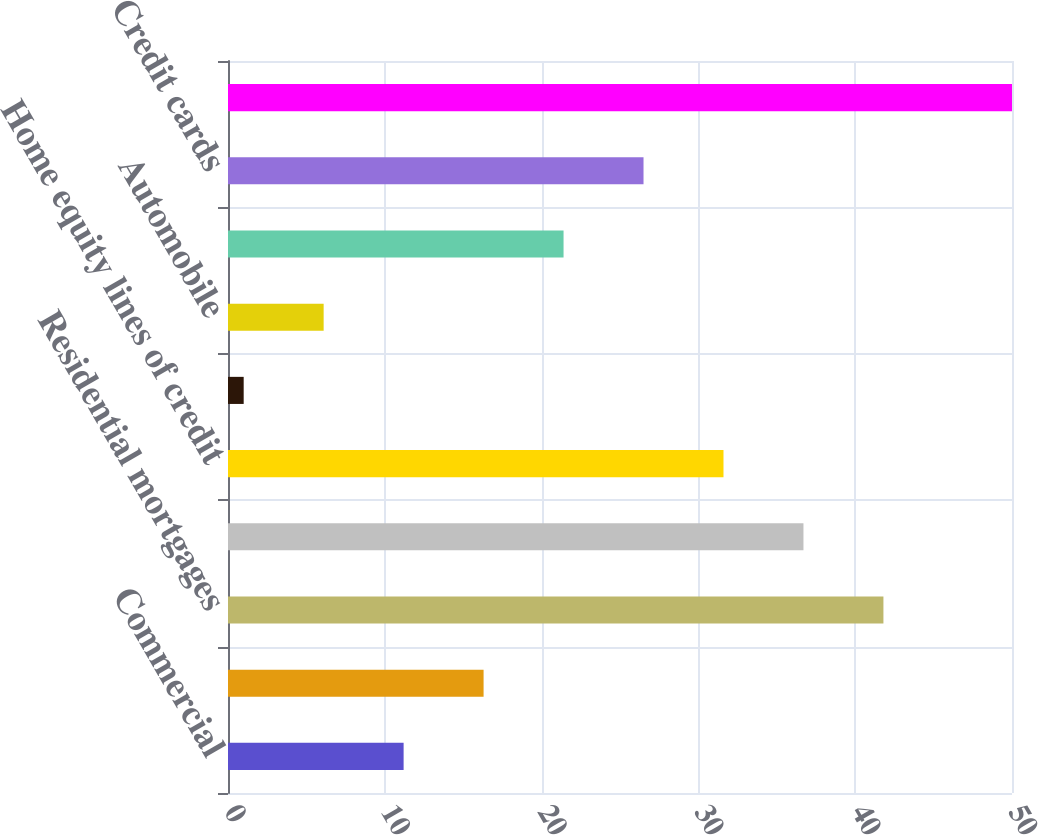<chart> <loc_0><loc_0><loc_500><loc_500><bar_chart><fcel>Commercial<fcel>Total commercial<fcel>Residential mortgages<fcel>Home equity loans<fcel>Home equity lines of credit<fcel>Home equity loans serviced by<fcel>Automobile<fcel>Student<fcel>Credit cards<fcel>Total retail<nl><fcel>11.2<fcel>16.3<fcel>41.8<fcel>36.7<fcel>31.6<fcel>1<fcel>6.1<fcel>21.4<fcel>26.5<fcel>50<nl></chart> 